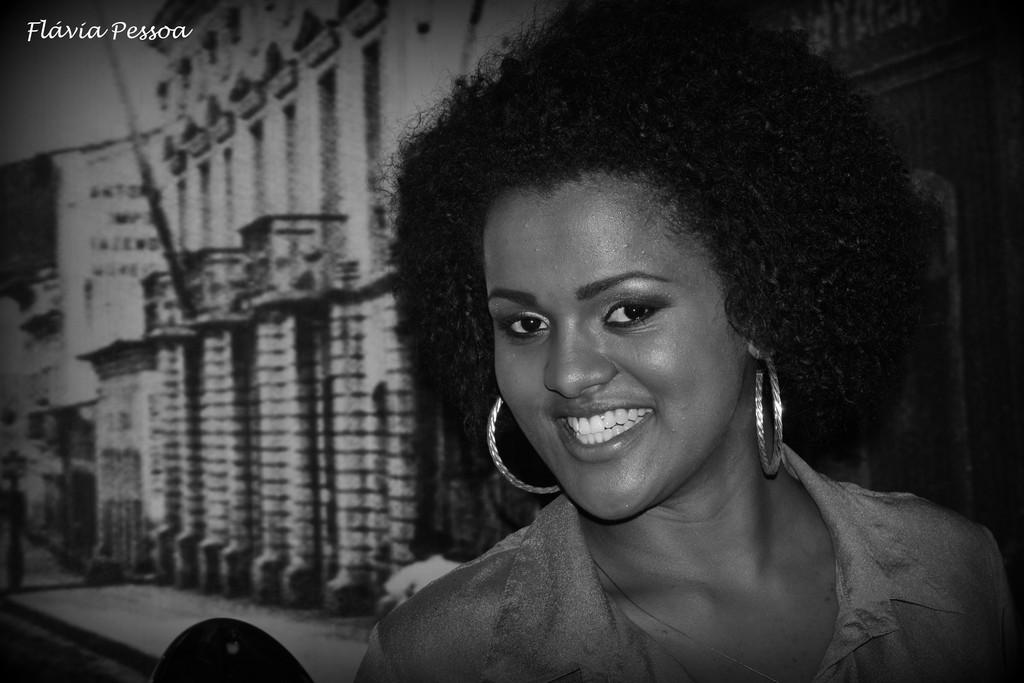Who is the main subject in the image? There is a lady in the image. Where is the lady located in the image? The lady is on the right side of the image. What expression does the lady have? The lady is smiling. What can be seen in the background of the image? There are buildings and a path in the background of the image. What type of rock is the lady holding in the image? There is no rock present in the image; the lady is not holding anything. 